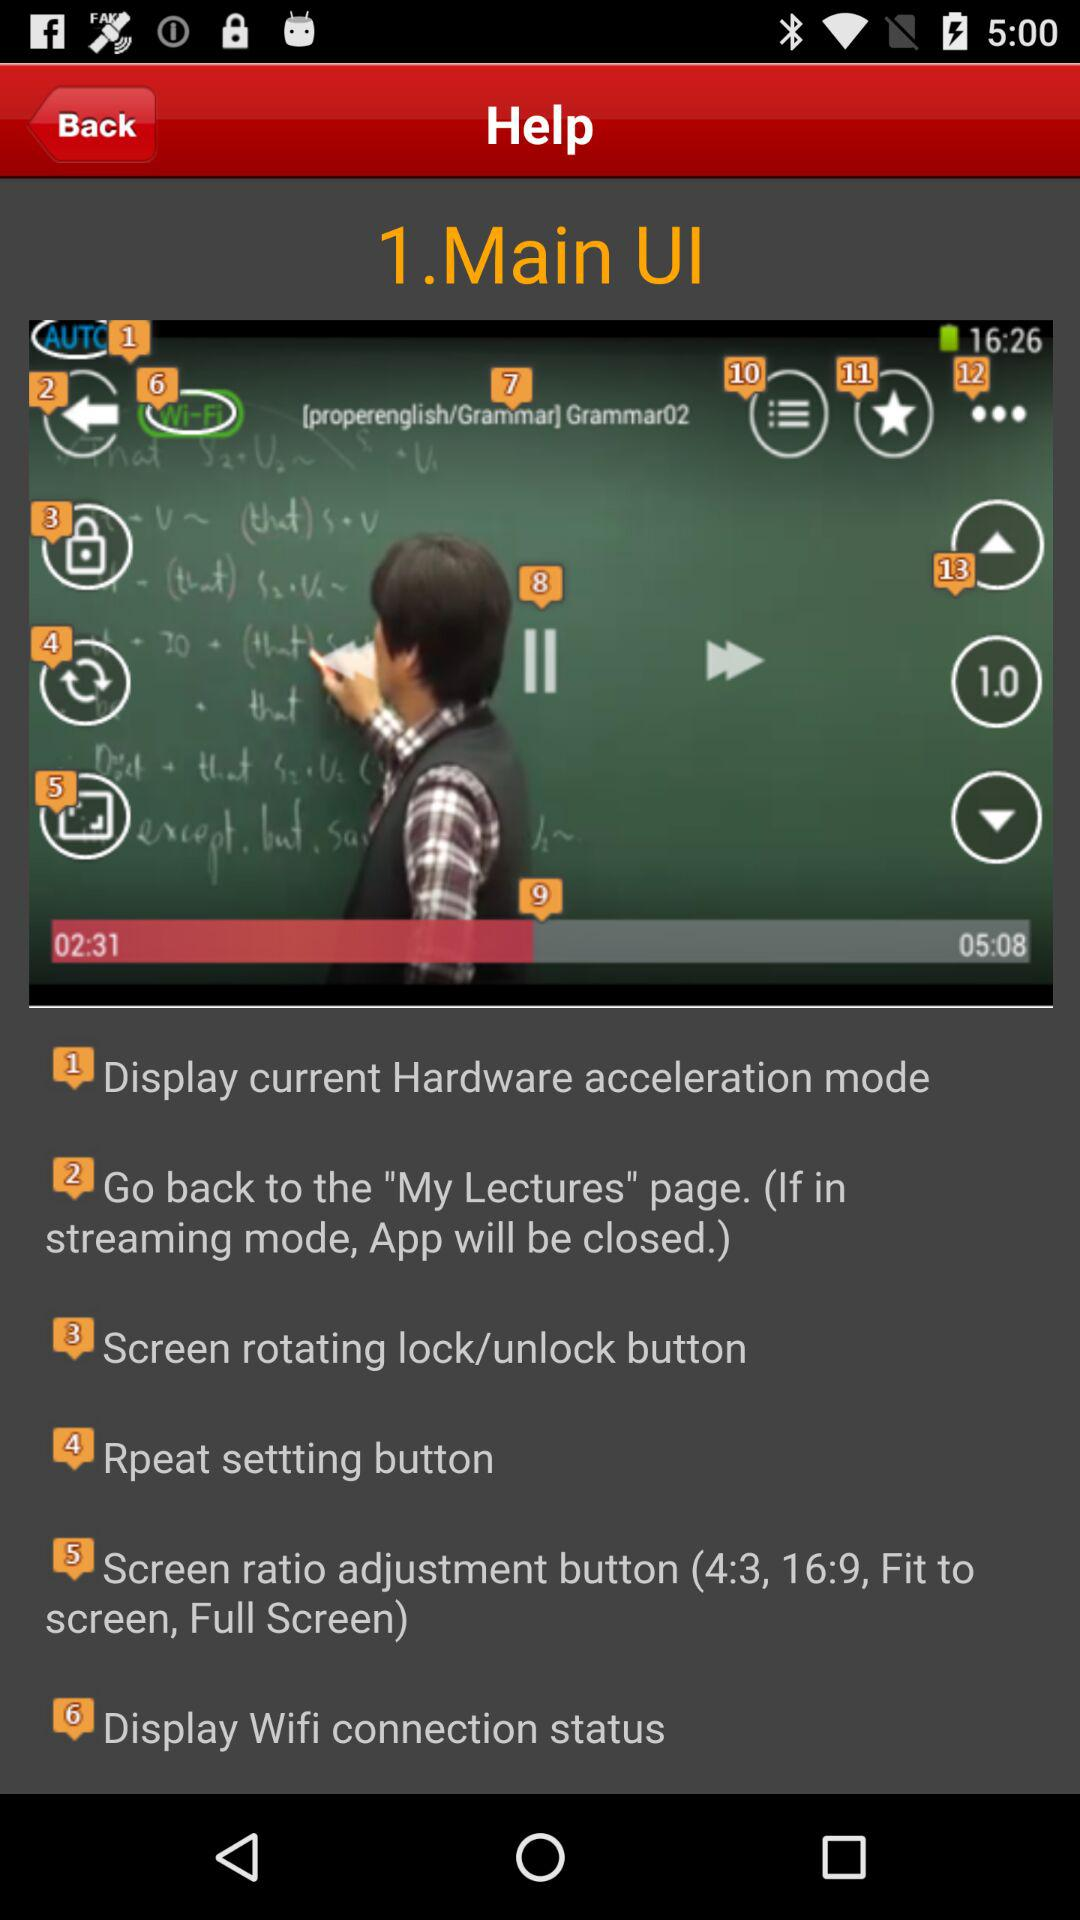What is the title of the video? The title of the video is "Main UI". 